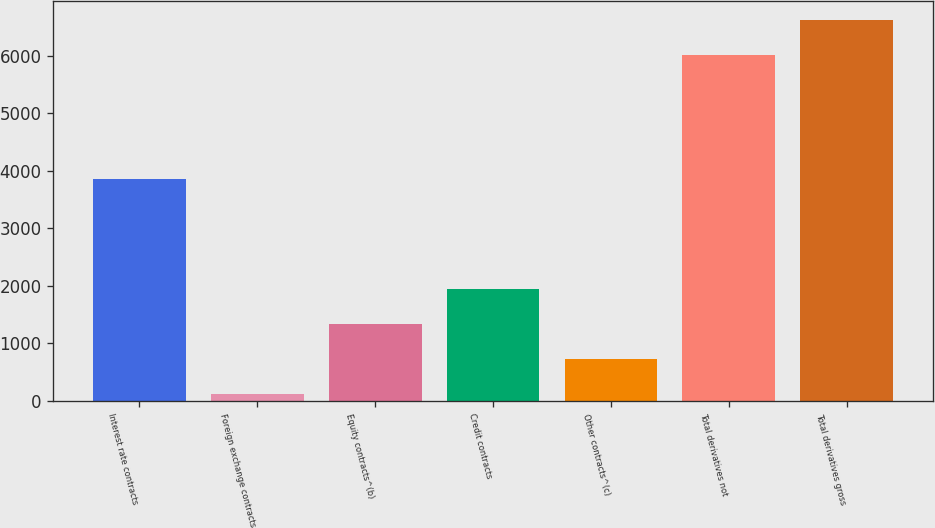Convert chart to OTSL. <chart><loc_0><loc_0><loc_500><loc_500><bar_chart><fcel>Interest rate contracts<fcel>Foreign exchange contracts<fcel>Equity contracts^(b)<fcel>Credit contracts<fcel>Other contracts^(c)<fcel>Total derivatives not<fcel>Total derivatives gross<nl><fcel>3849<fcel>129<fcel>1346<fcel>1954.5<fcel>737.5<fcel>6009<fcel>6617.5<nl></chart> 